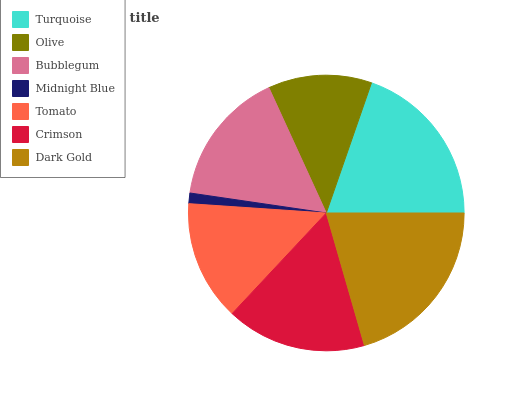Is Midnight Blue the minimum?
Answer yes or no. Yes. Is Dark Gold the maximum?
Answer yes or no. Yes. Is Olive the minimum?
Answer yes or no. No. Is Olive the maximum?
Answer yes or no. No. Is Turquoise greater than Olive?
Answer yes or no. Yes. Is Olive less than Turquoise?
Answer yes or no. Yes. Is Olive greater than Turquoise?
Answer yes or no. No. Is Turquoise less than Olive?
Answer yes or no. No. Is Bubblegum the high median?
Answer yes or no. Yes. Is Bubblegum the low median?
Answer yes or no. Yes. Is Crimson the high median?
Answer yes or no. No. Is Midnight Blue the low median?
Answer yes or no. No. 